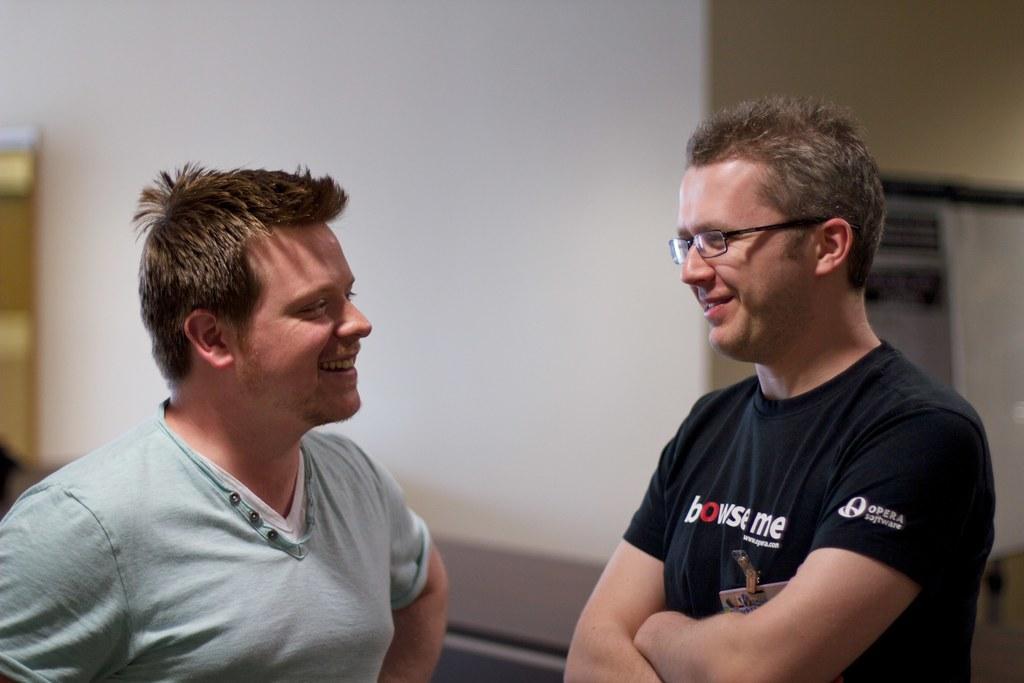In one or two sentences, can you explain what this image depicts? Here we can see two men and they are smiling. In the background we can see wall. 